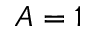<formula> <loc_0><loc_0><loc_500><loc_500>A = 1</formula> 